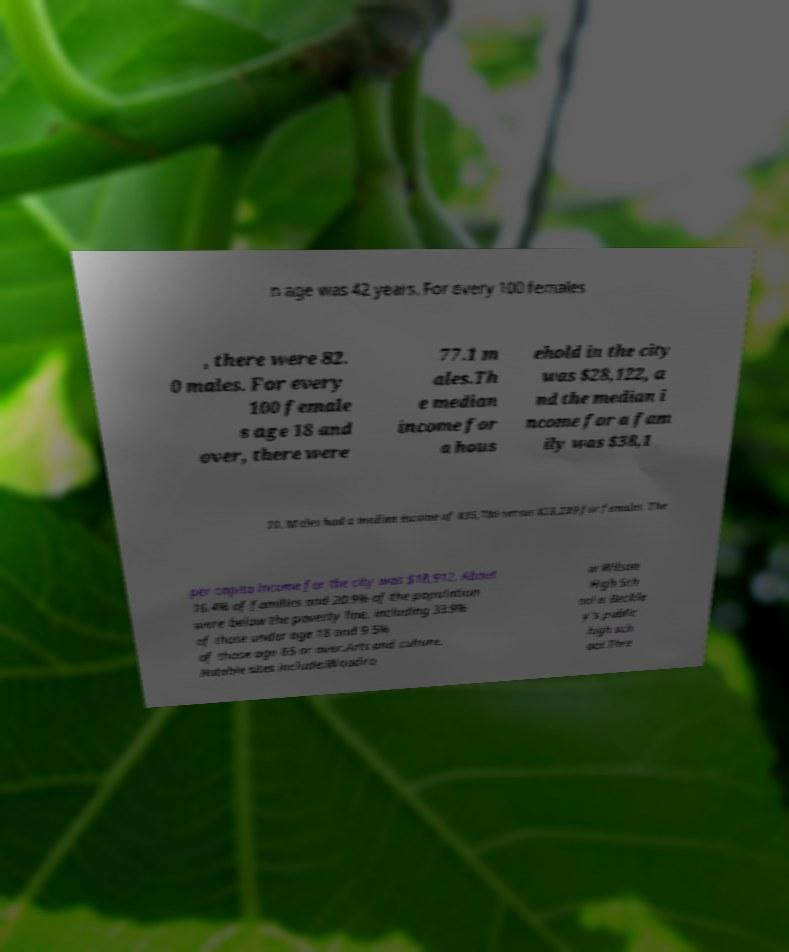There's text embedded in this image that I need extracted. Can you transcribe it verbatim? n age was 42 years. For every 100 females , there were 82. 0 males. For every 100 female s age 18 and over, there were 77.1 m ales.Th e median income for a hous ehold in the city was $28,122, a nd the median i ncome for a fam ily was $38,1 10. Males had a median income of $35,780 versus $23,239 for females. The per capita income for the city was $18,912. About 16.4% of families and 20.9% of the population were below the poverty line, including 33.9% of those under age 18 and 9.5% of those age 65 or over.Arts and culture. Notable sites include:Woodro w Wilson High Sch ool is Beckle y's public high sch ool.Thre 